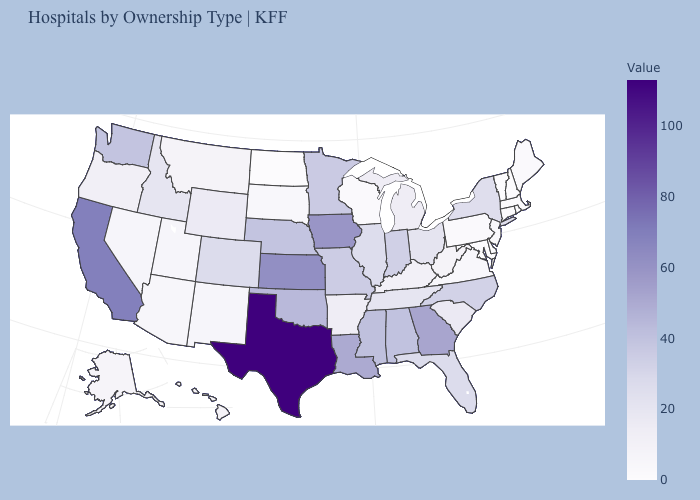Which states have the lowest value in the USA?
Give a very brief answer. Delaware, Maryland, New Hampshire, North Dakota, Rhode Island, Vermont. Which states have the lowest value in the USA?
Keep it brief. Delaware, Maryland, New Hampshire, North Dakota, Rhode Island, Vermont. Among the states that border Connecticut , which have the highest value?
Be succinct. New York. Does Minnesota have a higher value than North Dakota?
Give a very brief answer. Yes. Among the states that border Rhode Island , which have the highest value?
Short answer required. Connecticut, Massachusetts. 